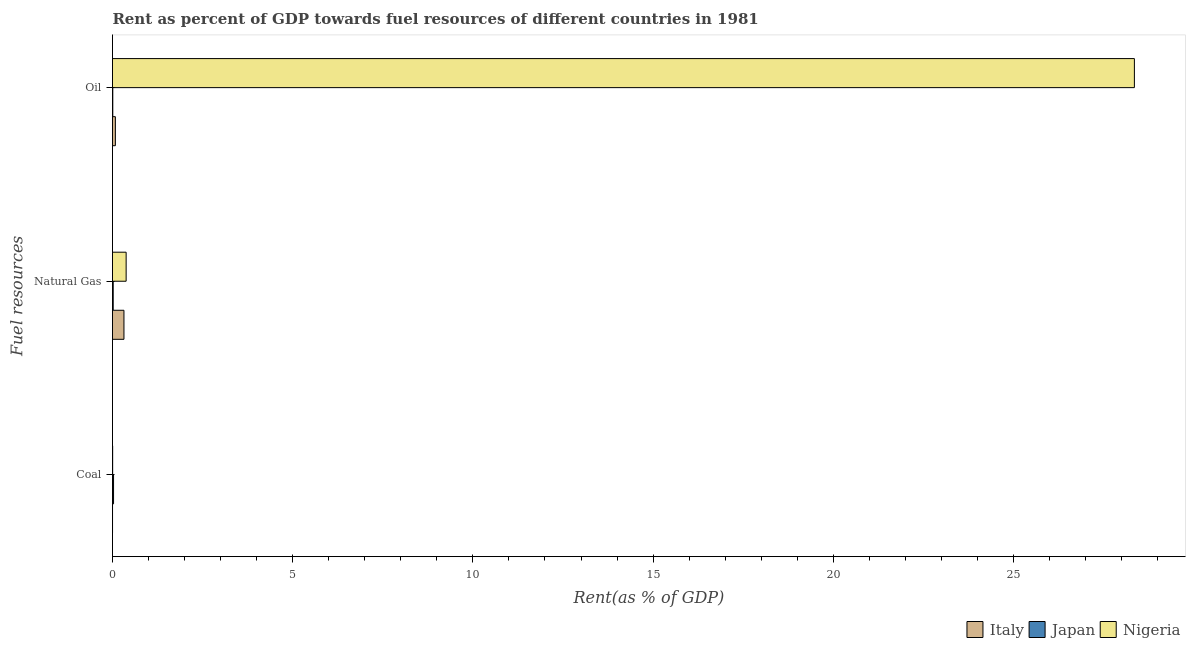How many groups of bars are there?
Give a very brief answer. 3. Are the number of bars on each tick of the Y-axis equal?
Your answer should be compact. Yes. How many bars are there on the 2nd tick from the top?
Keep it short and to the point. 3. What is the label of the 3rd group of bars from the top?
Your answer should be very brief. Coal. What is the rent towards natural gas in Japan?
Your answer should be compact. 0.02. Across all countries, what is the maximum rent towards coal?
Provide a short and direct response. 0.03. Across all countries, what is the minimum rent towards coal?
Offer a very short reply. 0. In which country was the rent towards coal maximum?
Ensure brevity in your answer.  Japan. What is the total rent towards coal in the graph?
Keep it short and to the point. 0.03. What is the difference between the rent towards coal in Nigeria and that in Japan?
Provide a short and direct response. -0.02. What is the difference between the rent towards coal in Italy and the rent towards natural gas in Nigeria?
Your answer should be compact. -0.38. What is the average rent towards coal per country?
Make the answer very short. 0.01. What is the difference between the rent towards coal and rent towards oil in Japan?
Offer a terse response. 0.02. What is the ratio of the rent towards natural gas in Japan to that in Italy?
Keep it short and to the point. 0.06. Is the difference between the rent towards natural gas in Italy and Nigeria greater than the difference between the rent towards coal in Italy and Nigeria?
Give a very brief answer. No. What is the difference between the highest and the second highest rent towards natural gas?
Keep it short and to the point. 0.06. What is the difference between the highest and the lowest rent towards oil?
Offer a very short reply. 28.35. What does the 2nd bar from the top in Coal represents?
Ensure brevity in your answer.  Japan. How many countries are there in the graph?
Make the answer very short. 3. Does the graph contain any zero values?
Provide a succinct answer. No. How many legend labels are there?
Make the answer very short. 3. How are the legend labels stacked?
Offer a very short reply. Horizontal. What is the title of the graph?
Your response must be concise. Rent as percent of GDP towards fuel resources of different countries in 1981. Does "Fragile and conflict affected situations" appear as one of the legend labels in the graph?
Ensure brevity in your answer.  No. What is the label or title of the X-axis?
Make the answer very short. Rent(as % of GDP). What is the label or title of the Y-axis?
Provide a short and direct response. Fuel resources. What is the Rent(as % of GDP) in Italy in Coal?
Your answer should be compact. 0. What is the Rent(as % of GDP) of Japan in Coal?
Ensure brevity in your answer.  0.03. What is the Rent(as % of GDP) in Nigeria in Coal?
Your answer should be very brief. 0. What is the Rent(as % of GDP) in Italy in Natural Gas?
Your response must be concise. 0.32. What is the Rent(as % of GDP) of Japan in Natural Gas?
Give a very brief answer. 0.02. What is the Rent(as % of GDP) in Nigeria in Natural Gas?
Offer a terse response. 0.38. What is the Rent(as % of GDP) in Italy in Oil?
Keep it short and to the point. 0.08. What is the Rent(as % of GDP) of Japan in Oil?
Provide a succinct answer. 0.01. What is the Rent(as % of GDP) in Nigeria in Oil?
Your answer should be compact. 28.35. Across all Fuel resources, what is the maximum Rent(as % of GDP) in Italy?
Ensure brevity in your answer.  0.32. Across all Fuel resources, what is the maximum Rent(as % of GDP) of Japan?
Keep it short and to the point. 0.03. Across all Fuel resources, what is the maximum Rent(as % of GDP) of Nigeria?
Provide a succinct answer. 28.35. Across all Fuel resources, what is the minimum Rent(as % of GDP) of Italy?
Keep it short and to the point. 0. Across all Fuel resources, what is the minimum Rent(as % of GDP) of Japan?
Provide a short and direct response. 0.01. Across all Fuel resources, what is the minimum Rent(as % of GDP) in Nigeria?
Your answer should be very brief. 0. What is the total Rent(as % of GDP) in Italy in the graph?
Make the answer very short. 0.4. What is the total Rent(as % of GDP) in Japan in the graph?
Provide a succinct answer. 0.06. What is the total Rent(as % of GDP) in Nigeria in the graph?
Give a very brief answer. 28.74. What is the difference between the Rent(as % of GDP) of Italy in Coal and that in Natural Gas?
Your answer should be compact. -0.32. What is the difference between the Rent(as % of GDP) of Japan in Coal and that in Natural Gas?
Your answer should be very brief. 0.01. What is the difference between the Rent(as % of GDP) of Nigeria in Coal and that in Natural Gas?
Your response must be concise. -0.37. What is the difference between the Rent(as % of GDP) in Italy in Coal and that in Oil?
Your answer should be very brief. -0.08. What is the difference between the Rent(as % of GDP) of Japan in Coal and that in Oil?
Make the answer very short. 0.02. What is the difference between the Rent(as % of GDP) of Nigeria in Coal and that in Oil?
Offer a terse response. -28.35. What is the difference between the Rent(as % of GDP) of Italy in Natural Gas and that in Oil?
Your response must be concise. 0.24. What is the difference between the Rent(as % of GDP) in Japan in Natural Gas and that in Oil?
Your response must be concise. 0.01. What is the difference between the Rent(as % of GDP) in Nigeria in Natural Gas and that in Oil?
Provide a short and direct response. -27.98. What is the difference between the Rent(as % of GDP) of Italy in Coal and the Rent(as % of GDP) of Japan in Natural Gas?
Make the answer very short. -0.02. What is the difference between the Rent(as % of GDP) of Italy in Coal and the Rent(as % of GDP) of Nigeria in Natural Gas?
Make the answer very short. -0.38. What is the difference between the Rent(as % of GDP) of Japan in Coal and the Rent(as % of GDP) of Nigeria in Natural Gas?
Your answer should be very brief. -0.35. What is the difference between the Rent(as % of GDP) in Italy in Coal and the Rent(as % of GDP) in Japan in Oil?
Your answer should be very brief. -0.01. What is the difference between the Rent(as % of GDP) in Italy in Coal and the Rent(as % of GDP) in Nigeria in Oil?
Make the answer very short. -28.35. What is the difference between the Rent(as % of GDP) of Japan in Coal and the Rent(as % of GDP) of Nigeria in Oil?
Ensure brevity in your answer.  -28.33. What is the difference between the Rent(as % of GDP) of Italy in Natural Gas and the Rent(as % of GDP) of Japan in Oil?
Give a very brief answer. 0.31. What is the difference between the Rent(as % of GDP) in Italy in Natural Gas and the Rent(as % of GDP) in Nigeria in Oil?
Offer a very short reply. -28.04. What is the difference between the Rent(as % of GDP) of Japan in Natural Gas and the Rent(as % of GDP) of Nigeria in Oil?
Your answer should be very brief. -28.33. What is the average Rent(as % of GDP) in Italy per Fuel resources?
Provide a short and direct response. 0.13. What is the average Rent(as % of GDP) of Japan per Fuel resources?
Provide a short and direct response. 0.02. What is the average Rent(as % of GDP) in Nigeria per Fuel resources?
Provide a succinct answer. 9.58. What is the difference between the Rent(as % of GDP) of Italy and Rent(as % of GDP) of Japan in Coal?
Your answer should be very brief. -0.03. What is the difference between the Rent(as % of GDP) of Italy and Rent(as % of GDP) of Nigeria in Coal?
Your answer should be compact. -0. What is the difference between the Rent(as % of GDP) in Japan and Rent(as % of GDP) in Nigeria in Coal?
Ensure brevity in your answer.  0.02. What is the difference between the Rent(as % of GDP) in Italy and Rent(as % of GDP) in Japan in Natural Gas?
Your answer should be very brief. 0.3. What is the difference between the Rent(as % of GDP) of Italy and Rent(as % of GDP) of Nigeria in Natural Gas?
Provide a succinct answer. -0.06. What is the difference between the Rent(as % of GDP) in Japan and Rent(as % of GDP) in Nigeria in Natural Gas?
Ensure brevity in your answer.  -0.36. What is the difference between the Rent(as % of GDP) in Italy and Rent(as % of GDP) in Japan in Oil?
Offer a very short reply. 0.07. What is the difference between the Rent(as % of GDP) of Italy and Rent(as % of GDP) of Nigeria in Oil?
Your response must be concise. -28.27. What is the difference between the Rent(as % of GDP) in Japan and Rent(as % of GDP) in Nigeria in Oil?
Keep it short and to the point. -28.35. What is the ratio of the Rent(as % of GDP) in Italy in Coal to that in Natural Gas?
Your answer should be compact. 0. What is the ratio of the Rent(as % of GDP) of Japan in Coal to that in Natural Gas?
Offer a very short reply. 1.47. What is the ratio of the Rent(as % of GDP) of Nigeria in Coal to that in Natural Gas?
Your answer should be compact. 0.01. What is the ratio of the Rent(as % of GDP) in Italy in Coal to that in Oil?
Provide a short and direct response. 0.01. What is the ratio of the Rent(as % of GDP) of Japan in Coal to that in Oil?
Your response must be concise. 3.63. What is the ratio of the Rent(as % of GDP) of Italy in Natural Gas to that in Oil?
Offer a terse response. 3.98. What is the ratio of the Rent(as % of GDP) of Japan in Natural Gas to that in Oil?
Give a very brief answer. 2.47. What is the ratio of the Rent(as % of GDP) of Nigeria in Natural Gas to that in Oil?
Keep it short and to the point. 0.01. What is the difference between the highest and the second highest Rent(as % of GDP) in Italy?
Your answer should be compact. 0.24. What is the difference between the highest and the second highest Rent(as % of GDP) of Japan?
Your answer should be compact. 0.01. What is the difference between the highest and the second highest Rent(as % of GDP) in Nigeria?
Your response must be concise. 27.98. What is the difference between the highest and the lowest Rent(as % of GDP) in Italy?
Your answer should be very brief. 0.32. What is the difference between the highest and the lowest Rent(as % of GDP) in Japan?
Offer a very short reply. 0.02. What is the difference between the highest and the lowest Rent(as % of GDP) in Nigeria?
Offer a terse response. 28.35. 